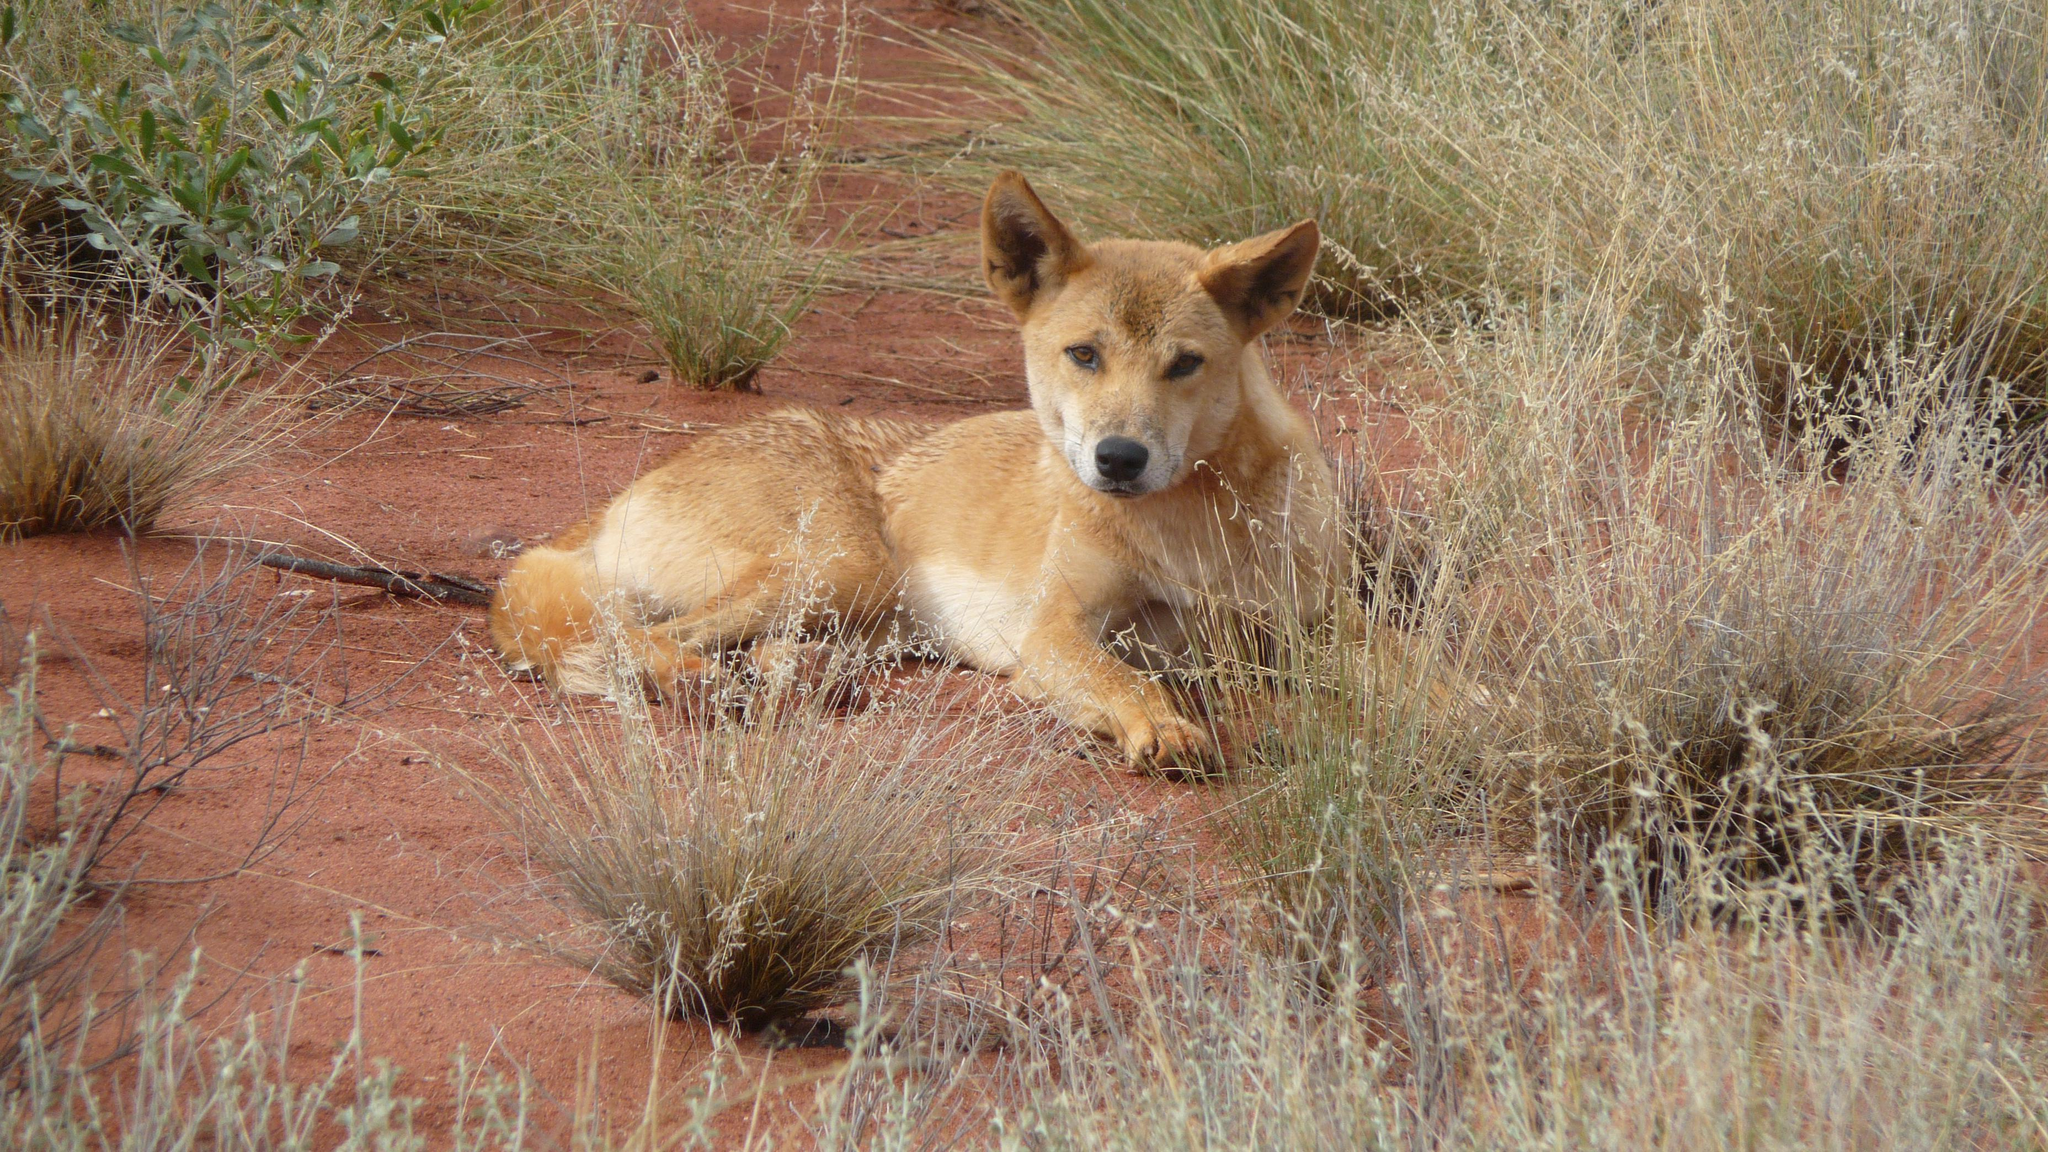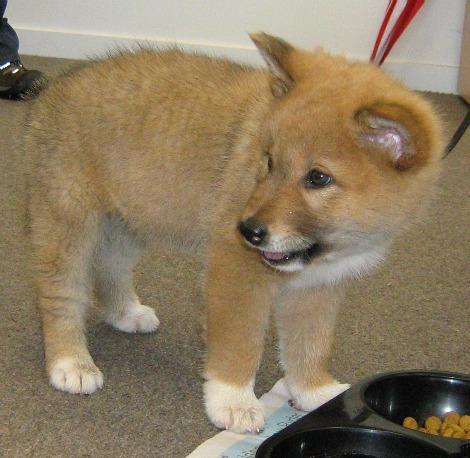The first image is the image on the left, the second image is the image on the right. Examine the images to the left and right. Is the description "The left image features one reclining orange dog, and the right image includes at least one standing orange puppy." accurate? Answer yes or no. Yes. The first image is the image on the left, the second image is the image on the right. Assess this claim about the two images: "The dog in the image on the left is laying down on the ground.". Correct or not? Answer yes or no. Yes. 